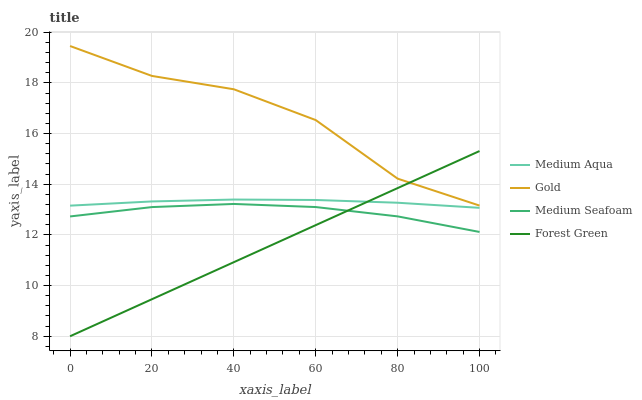Does Forest Green have the minimum area under the curve?
Answer yes or no. Yes. Does Gold have the maximum area under the curve?
Answer yes or no. Yes. Does Medium Aqua have the minimum area under the curve?
Answer yes or no. No. Does Medium Aqua have the maximum area under the curve?
Answer yes or no. No. Is Forest Green the smoothest?
Answer yes or no. Yes. Is Gold the roughest?
Answer yes or no. Yes. Is Medium Aqua the smoothest?
Answer yes or no. No. Is Medium Aqua the roughest?
Answer yes or no. No. Does Forest Green have the lowest value?
Answer yes or no. Yes. Does Medium Aqua have the lowest value?
Answer yes or no. No. Does Gold have the highest value?
Answer yes or no. Yes. Does Medium Aqua have the highest value?
Answer yes or no. No. Is Medium Seafoam less than Medium Aqua?
Answer yes or no. Yes. Is Gold greater than Medium Seafoam?
Answer yes or no. Yes. Does Gold intersect Forest Green?
Answer yes or no. Yes. Is Gold less than Forest Green?
Answer yes or no. No. Is Gold greater than Forest Green?
Answer yes or no. No. Does Medium Seafoam intersect Medium Aqua?
Answer yes or no. No. 